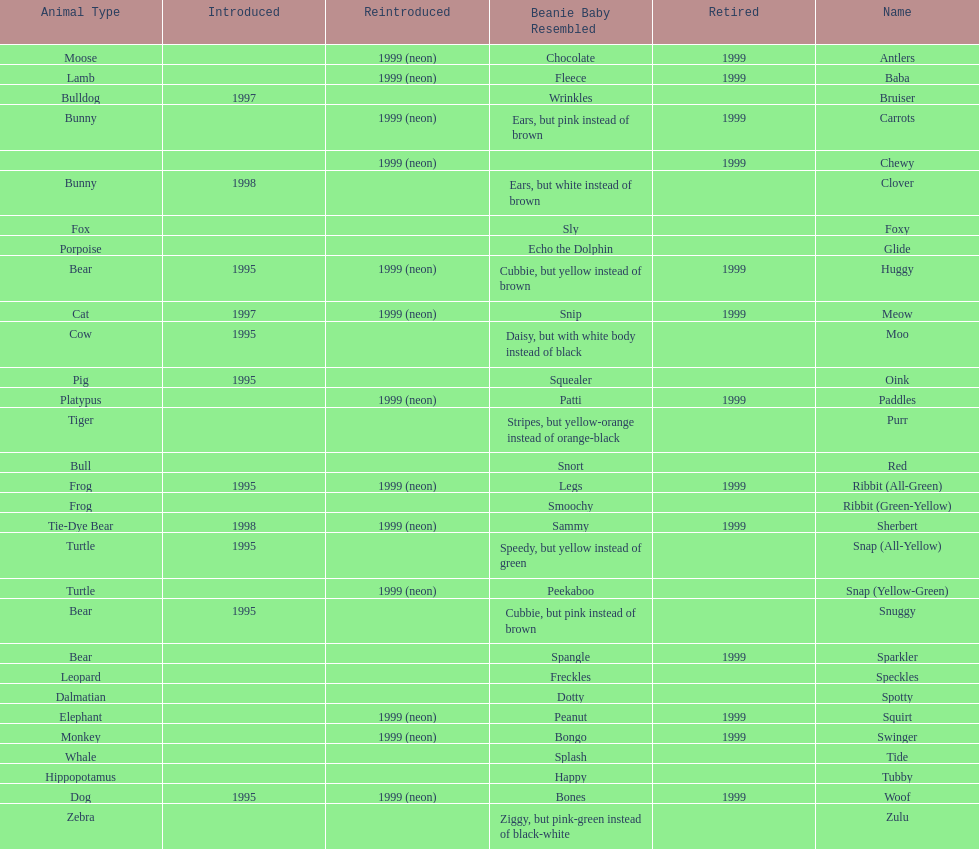Which animal type has the most pillow pals? Bear. 